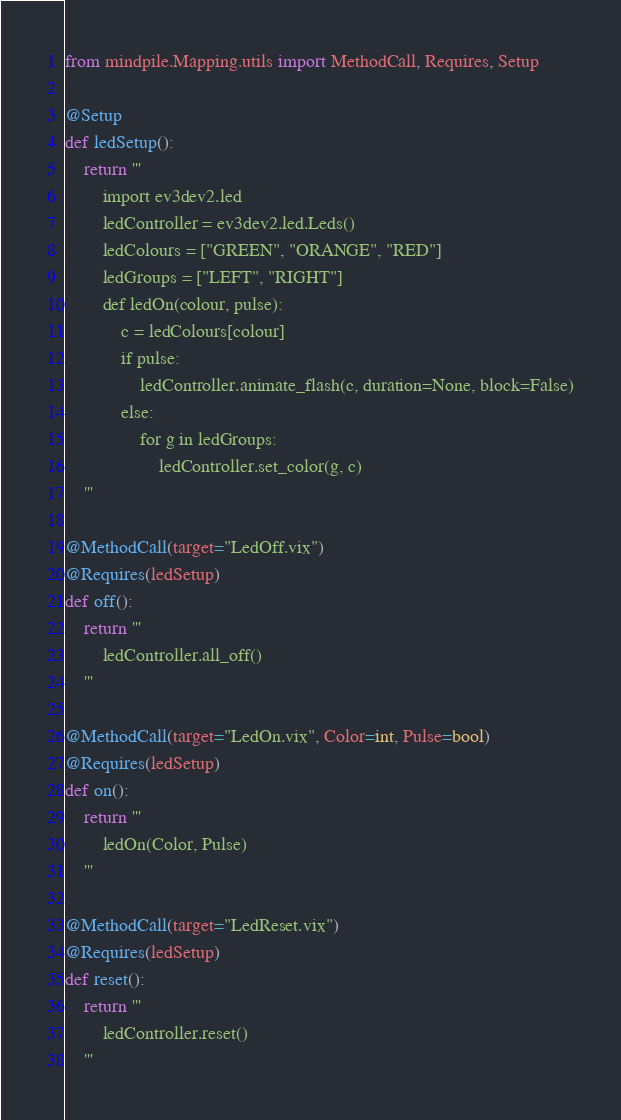Convert code to text. <code><loc_0><loc_0><loc_500><loc_500><_Python_>from mindpile.Mapping.utils import MethodCall, Requires, Setup

@Setup
def ledSetup():
    return '''
        import ev3dev2.led
        ledController = ev3dev2.led.Leds()
        ledColours = ["GREEN", "ORANGE", "RED"]
        ledGroups = ["LEFT", "RIGHT"]
        def ledOn(colour, pulse):
            c = ledColours[colour]
            if pulse:
                ledController.animate_flash(c, duration=None, block=False)
            else:
                for g in ledGroups:
                    ledController.set_color(g, c)
    '''

@MethodCall(target="LedOff.vix")
@Requires(ledSetup)
def off():
    return '''
        ledController.all_off()
    '''

@MethodCall(target="LedOn.vix", Color=int, Pulse=bool)
@Requires(ledSetup)
def on():
    return '''
        ledOn(Color, Pulse)
    '''

@MethodCall(target="LedReset.vix")
@Requires(ledSetup)
def reset():
    return '''
        ledController.reset()
    '''
</code> 